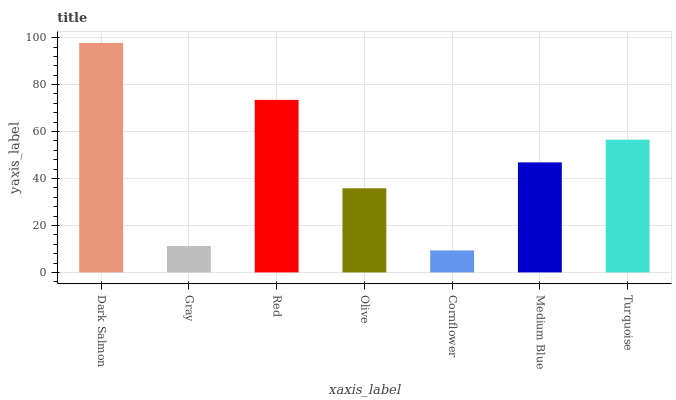Is Cornflower the minimum?
Answer yes or no. Yes. Is Dark Salmon the maximum?
Answer yes or no. Yes. Is Gray the minimum?
Answer yes or no. No. Is Gray the maximum?
Answer yes or no. No. Is Dark Salmon greater than Gray?
Answer yes or no. Yes. Is Gray less than Dark Salmon?
Answer yes or no. Yes. Is Gray greater than Dark Salmon?
Answer yes or no. No. Is Dark Salmon less than Gray?
Answer yes or no. No. Is Medium Blue the high median?
Answer yes or no. Yes. Is Medium Blue the low median?
Answer yes or no. Yes. Is Red the high median?
Answer yes or no. No. Is Cornflower the low median?
Answer yes or no. No. 